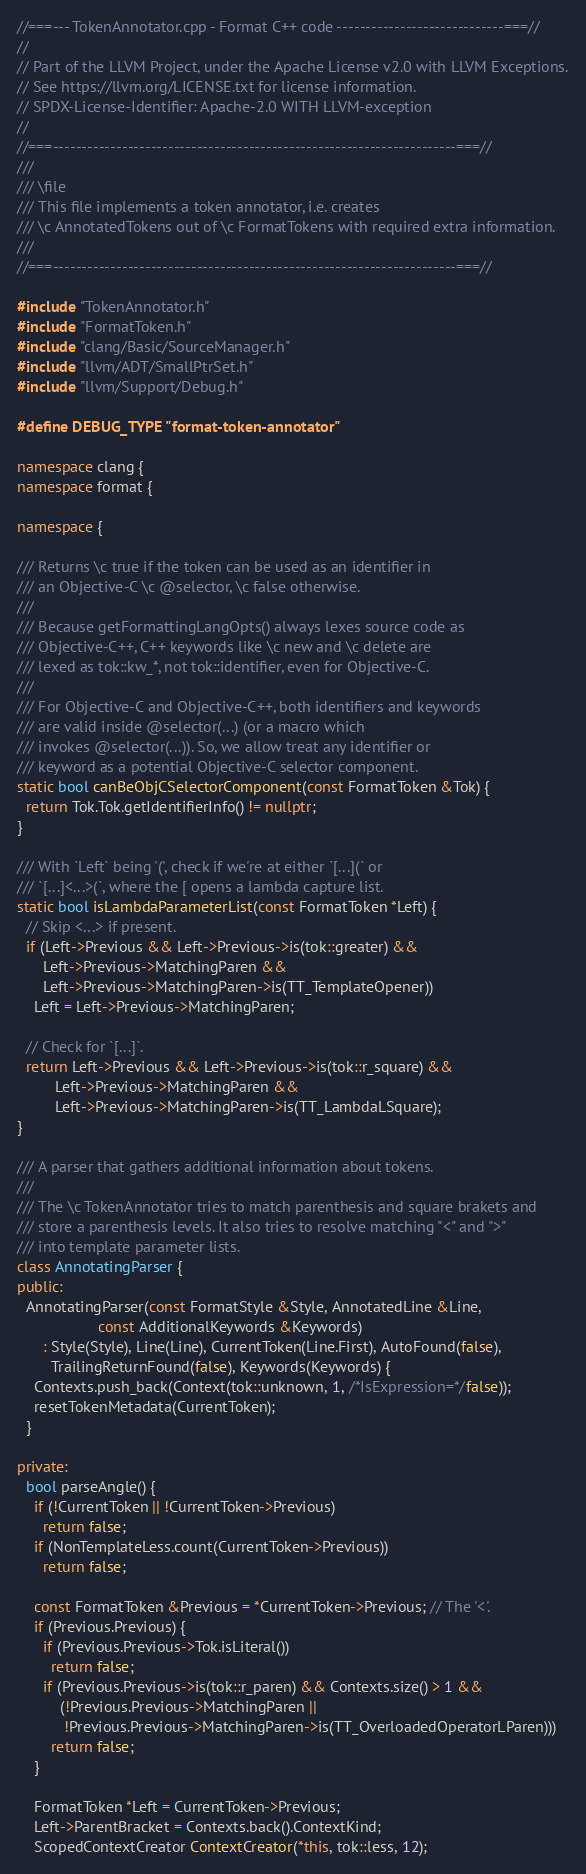<code> <loc_0><loc_0><loc_500><loc_500><_C++_>//===--- TokenAnnotator.cpp - Format C++ code -----------------------------===//
//
// Part of the LLVM Project, under the Apache License v2.0 with LLVM Exceptions.
// See https://llvm.org/LICENSE.txt for license information.
// SPDX-License-Identifier: Apache-2.0 WITH LLVM-exception
//
//===----------------------------------------------------------------------===//
///
/// \file
/// This file implements a token annotator, i.e. creates
/// \c AnnotatedTokens out of \c FormatTokens with required extra information.
///
//===----------------------------------------------------------------------===//

#include "TokenAnnotator.h"
#include "FormatToken.h"
#include "clang/Basic/SourceManager.h"
#include "llvm/ADT/SmallPtrSet.h"
#include "llvm/Support/Debug.h"

#define DEBUG_TYPE "format-token-annotator"

namespace clang {
namespace format {

namespace {

/// Returns \c true if the token can be used as an identifier in
/// an Objective-C \c @selector, \c false otherwise.
///
/// Because getFormattingLangOpts() always lexes source code as
/// Objective-C++, C++ keywords like \c new and \c delete are
/// lexed as tok::kw_*, not tok::identifier, even for Objective-C.
///
/// For Objective-C and Objective-C++, both identifiers and keywords
/// are valid inside @selector(...) (or a macro which
/// invokes @selector(...)). So, we allow treat any identifier or
/// keyword as a potential Objective-C selector component.
static bool canBeObjCSelectorComponent(const FormatToken &Tok) {
  return Tok.Tok.getIdentifierInfo() != nullptr;
}

/// With `Left` being '(', check if we're at either `[...](` or
/// `[...]<...>(`, where the [ opens a lambda capture list.
static bool isLambdaParameterList(const FormatToken *Left) {
  // Skip <...> if present.
  if (Left->Previous && Left->Previous->is(tok::greater) &&
      Left->Previous->MatchingParen &&
      Left->Previous->MatchingParen->is(TT_TemplateOpener))
    Left = Left->Previous->MatchingParen;

  // Check for `[...]`.
  return Left->Previous && Left->Previous->is(tok::r_square) &&
         Left->Previous->MatchingParen &&
         Left->Previous->MatchingParen->is(TT_LambdaLSquare);
}

/// A parser that gathers additional information about tokens.
///
/// The \c TokenAnnotator tries to match parenthesis and square brakets and
/// store a parenthesis levels. It also tries to resolve matching "<" and ">"
/// into template parameter lists.
class AnnotatingParser {
public:
  AnnotatingParser(const FormatStyle &Style, AnnotatedLine &Line,
                   const AdditionalKeywords &Keywords)
      : Style(Style), Line(Line), CurrentToken(Line.First), AutoFound(false),
        TrailingReturnFound(false), Keywords(Keywords) {
    Contexts.push_back(Context(tok::unknown, 1, /*IsExpression=*/false));
    resetTokenMetadata(CurrentToken);
  }

private:
  bool parseAngle() {
    if (!CurrentToken || !CurrentToken->Previous)
      return false;
    if (NonTemplateLess.count(CurrentToken->Previous))
      return false;

    const FormatToken &Previous = *CurrentToken->Previous; // The '<'.
    if (Previous.Previous) {
      if (Previous.Previous->Tok.isLiteral())
        return false;
      if (Previous.Previous->is(tok::r_paren) && Contexts.size() > 1 &&
          (!Previous.Previous->MatchingParen ||
           !Previous.Previous->MatchingParen->is(TT_OverloadedOperatorLParen)))
        return false;
    }

    FormatToken *Left = CurrentToken->Previous;
    Left->ParentBracket = Contexts.back().ContextKind;
    ScopedContextCreator ContextCreator(*this, tok::less, 12);
</code> 